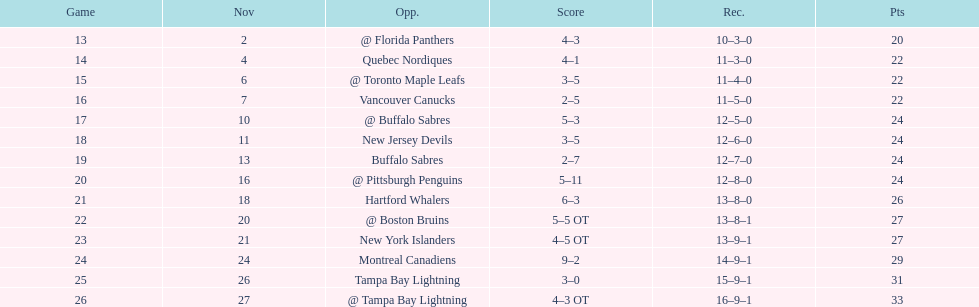The 1993-1994 flyers missed the playoffs again. how many consecutive seasons up until 93-94 did the flyers miss the playoffs? 5. 